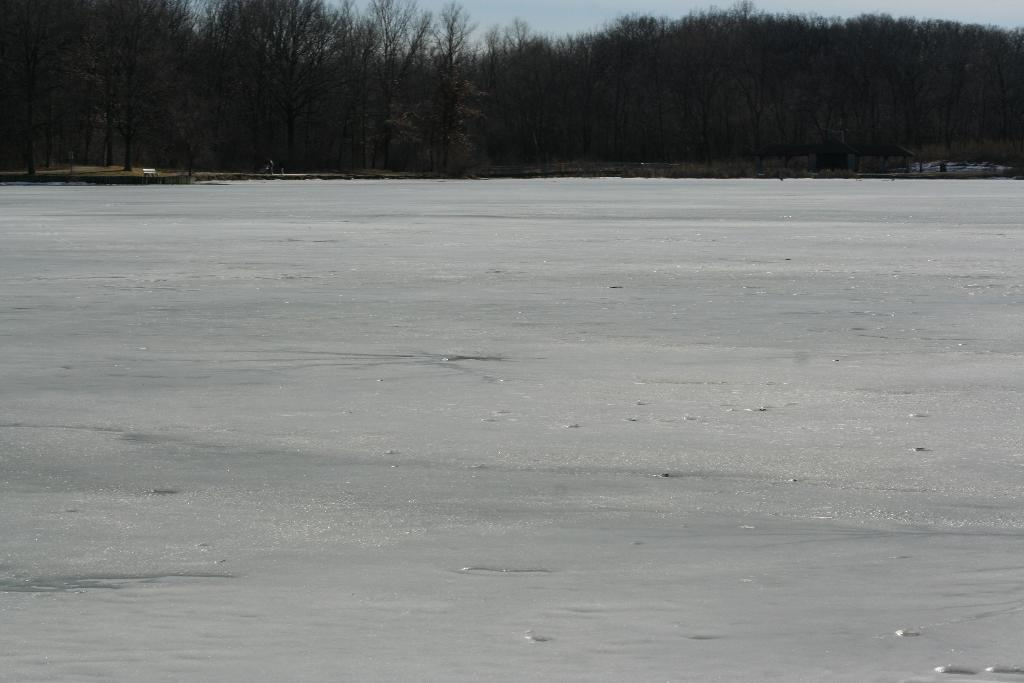What is the primary element that makes up the image? The image consists of snow. What can be seen at the bottom of the image? There is water at the bottom of the image. What type of natural environment is visible in the background of the image? There are trees in the background of the image. What is visible at the top of the image? The sky is visible at the top of the image. What color bead is hanging from the tree in the image? There is no bead hanging from the tree in the image; it only features snow, water, trees, and the sky. What type of shirt is the person wearing in the image? There is no person present in the image, so it is not possible to determine what type of shirt they might be wearing. 